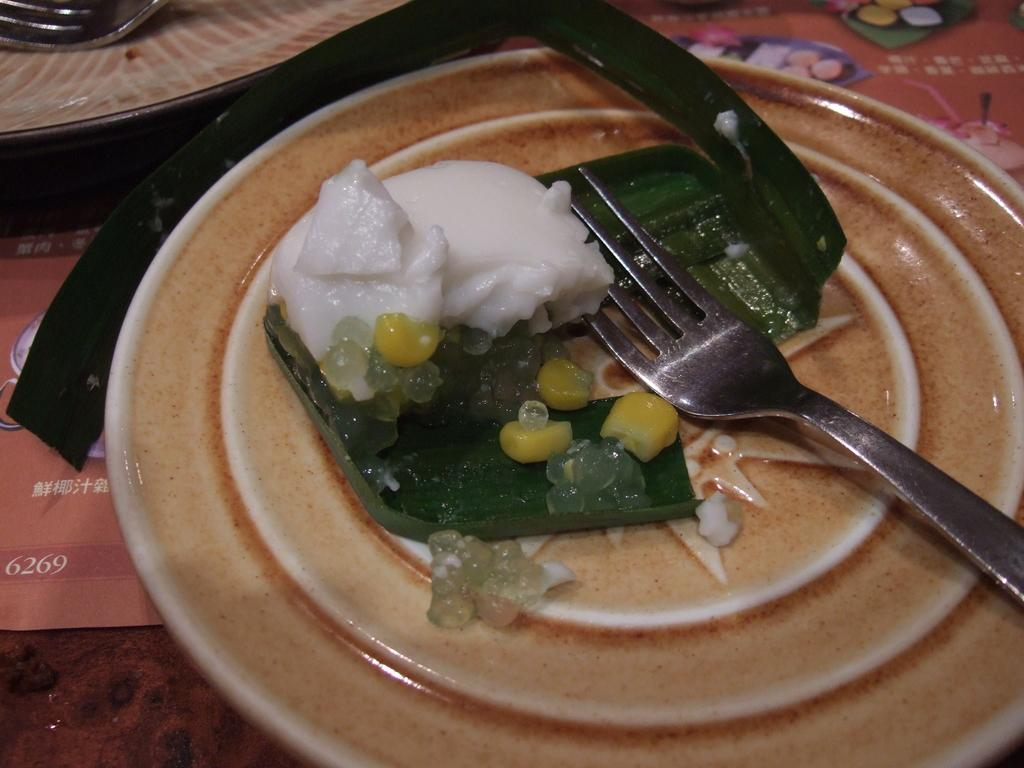What is on the plate that is visible in the image? There is a plate with food items in the image. What utensil can be seen in the image? There is a fork in the image. What type of street is visible in the image? There is no street present in the image; it only features a plate with food items and a fork. Can you see a stamp on any of the food items in the image? There is no stamp visible on any of the food items in the image. 